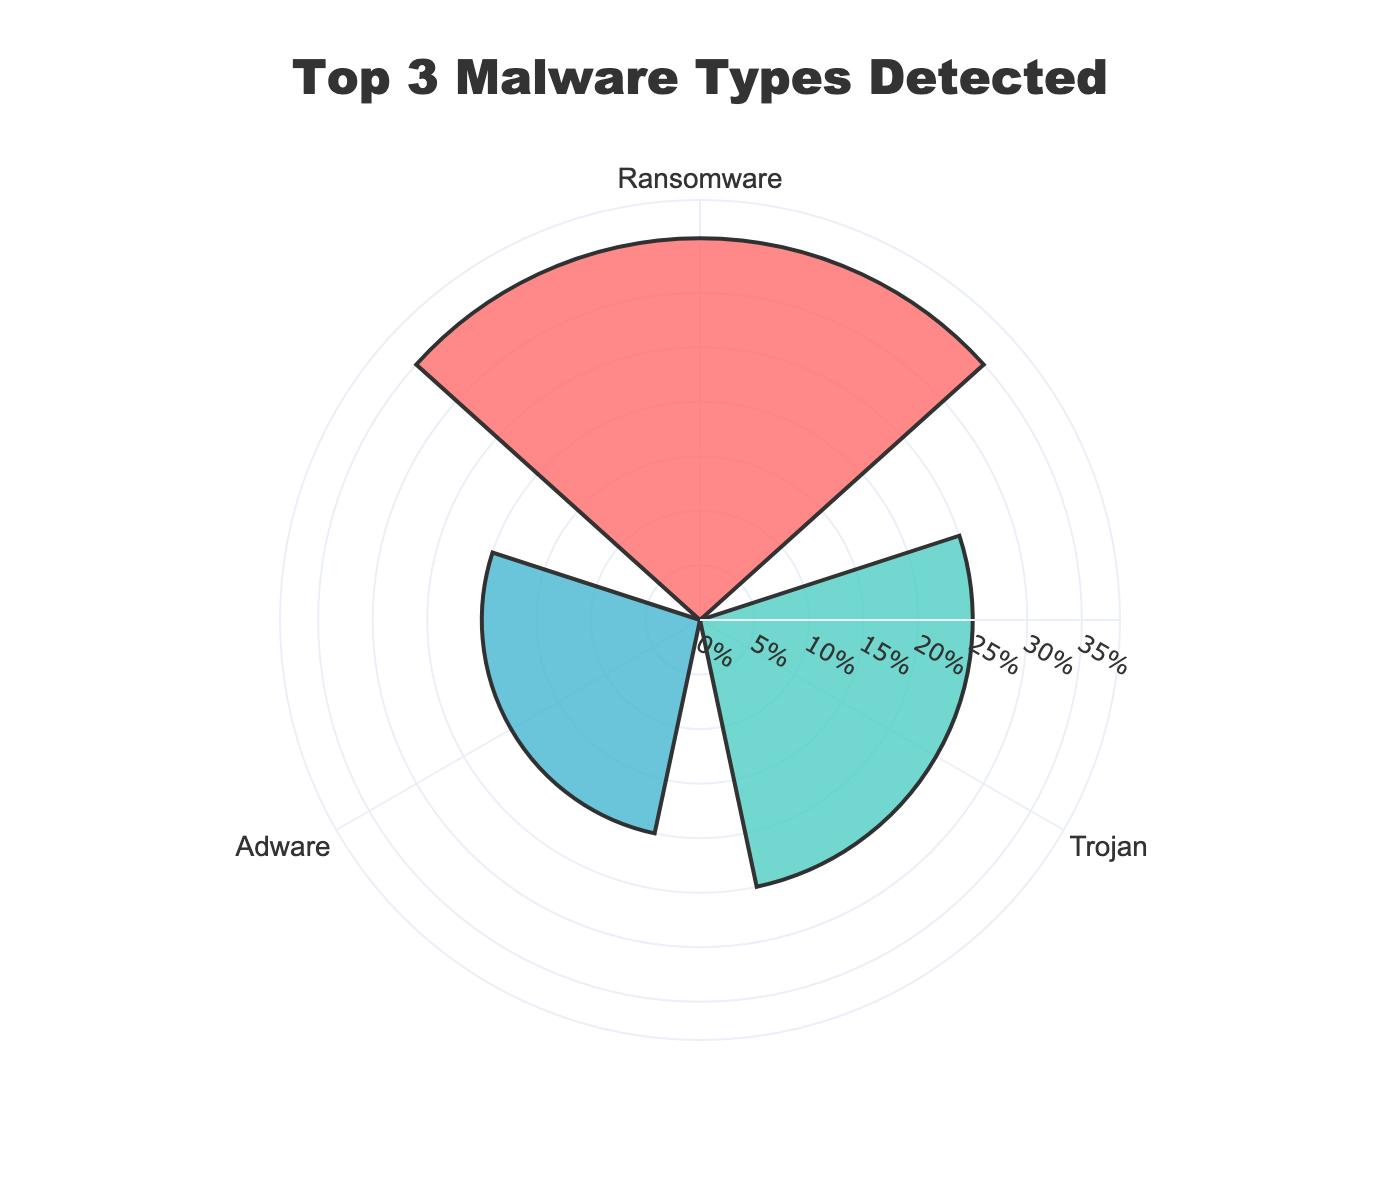What is the title of the figure? The title of the figure is located at the top center of the graph.
Answer: Top 3 Malware Types Detected How many malware types are displayed on the plot? By looking at the number of sections or categories in the chart, we see three different malware types.
Answer: 3 Which malware type has the highest detection percentage? The detection percentage is represented by the radial extent in the plot. The furthest extending bar corresponds to Ransomware.
Answer: Ransomware How much higher is the Ransomware percentage compared to the Spyware percentage? Ransomware has a percentage of 35%, and Spyware has 20%. Subtract Spyware’s percentage from Ransomware’s percentage: 35% - 20% = 15%.
Answer: 15% How does the detection percentage of Trojans compare to Adware? Trojans have a detection percentage of 25%, which is 5% more than Adware's 20%.
Answer: Trojans have 5% higher detection percentage than Adware What are the marker colors for each malware type in the chart? The colors of the markers can be observed directly in the figure: Ransomware is red, Trojan is teal, and Adware is blue.
Answer: Ransomware: red, Trojan: teal, Adware: blue What is the combined percentage of the top two malware types? Ransomware has 35% and Trojan has 25%. Adding these gives: 35% + 25% = 60%.
Answer: 60% What proportion of the total does Adware contribute among the top three malware types? The total detection percentage for the top three types is 80% (35% + 25% + 20%). Adware’s contribution is 20%. The proportion is 20% / 80% = 0.25 or 25%.
Answer: 25% If Spyware were included, what would be the new total detection percentage of the top four malware types? The current percentages for Ransomware, Trojan, and Adware add up to 80%. Adding Spyware’s 20% gives: 80% + 20% = 100%.
Answer: 100% 